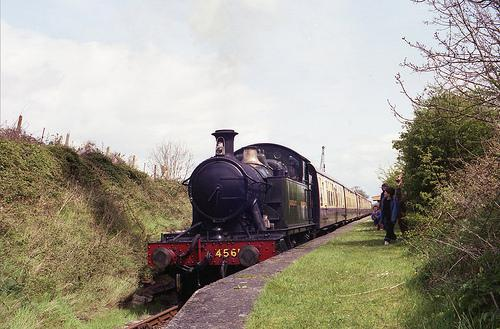Question: what mode of transportation is in the picture?
Choices:
A. Car.
B. Truck.
C. Boat.
D. Train.
Answer with the letter. Answer: D Question: what are the numbers seen on the front of the train?
Choices:
A. 666.
B. 456.
C. 768.
D. 345.
Answer with the letter. Answer: B Question: what is on the ground beside the tracks?
Choices:
A. Gravel.
B. Grass.
C. Flowers.
D. Trees.
Answer with the letter. Answer: B Question: what color is the sky?
Choices:
A. Red.
B. White.
C. Grey.
D. Blue.
Answer with the letter. Answer: D 